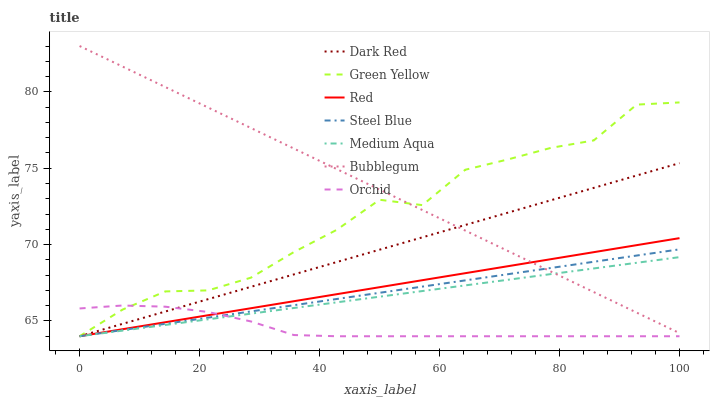Does Orchid have the minimum area under the curve?
Answer yes or no. Yes. Does Bubblegum have the maximum area under the curve?
Answer yes or no. Yes. Does Steel Blue have the minimum area under the curve?
Answer yes or no. No. Does Steel Blue have the maximum area under the curve?
Answer yes or no. No. Is Medium Aqua the smoothest?
Answer yes or no. Yes. Is Green Yellow the roughest?
Answer yes or no. Yes. Is Steel Blue the smoothest?
Answer yes or no. No. Is Steel Blue the roughest?
Answer yes or no. No. Does Dark Red have the lowest value?
Answer yes or no. Yes. Does Bubblegum have the lowest value?
Answer yes or no. No. Does Bubblegum have the highest value?
Answer yes or no. Yes. Does Steel Blue have the highest value?
Answer yes or no. No. Is Orchid less than Bubblegum?
Answer yes or no. Yes. Is Bubblegum greater than Orchid?
Answer yes or no. Yes. Does Orchid intersect Red?
Answer yes or no. Yes. Is Orchid less than Red?
Answer yes or no. No. Is Orchid greater than Red?
Answer yes or no. No. Does Orchid intersect Bubblegum?
Answer yes or no. No. 